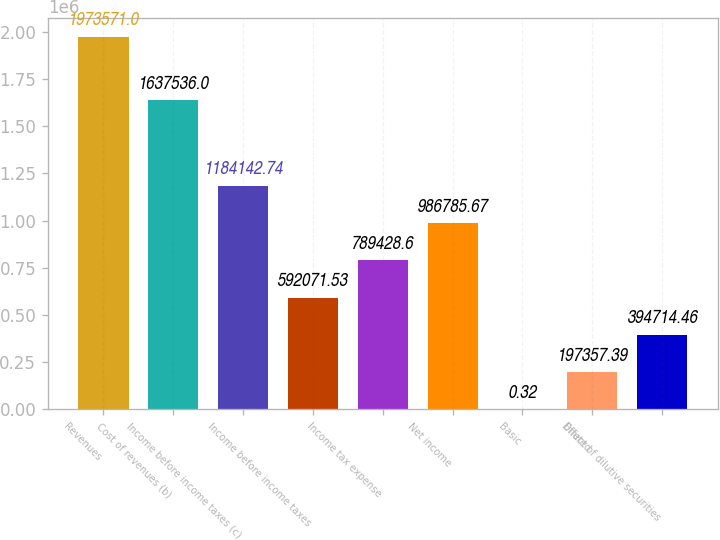<chart> <loc_0><loc_0><loc_500><loc_500><bar_chart><fcel>Revenues<fcel>Cost of revenues (b)<fcel>Income before income taxes (c)<fcel>Income before income taxes<fcel>Income tax expense<fcel>Net income<fcel>Basic<fcel>Diluted<fcel>Effect of dilutive securities<nl><fcel>1.97357e+06<fcel>1.63754e+06<fcel>1.18414e+06<fcel>592072<fcel>789429<fcel>986786<fcel>0.32<fcel>197357<fcel>394714<nl></chart> 